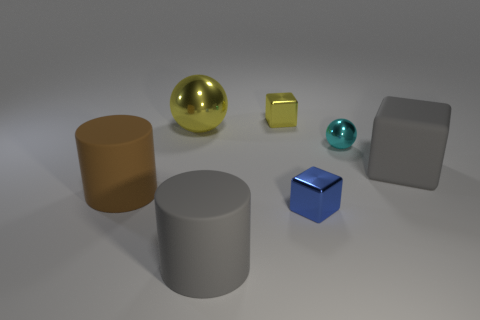What colors are the objects in the image? The objects in the image include a gold sphere, a bronze cylinder, a yellow cube, a blue cube, a turquoise sphere, and a gray cube and cylinder. The colors range from metallic shades to solid colors. 